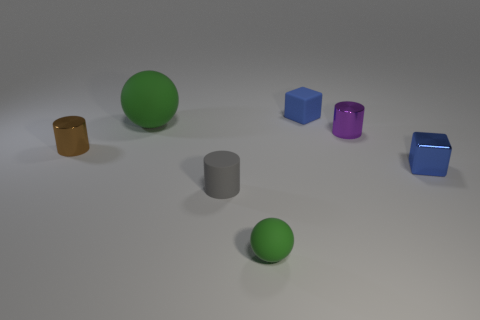Subtract all brown cylinders. How many cylinders are left? 2 Add 3 big matte things. How many objects exist? 10 Subtract all purple cylinders. How many cylinders are left? 2 Subtract all blocks. How many objects are left? 5 Subtract 0 purple spheres. How many objects are left? 7 Subtract all brown cylinders. Subtract all purple balls. How many cylinders are left? 2 Subtract all small purple cylinders. Subtract all purple metal cylinders. How many objects are left? 5 Add 5 purple shiny objects. How many purple shiny objects are left? 6 Add 6 blue rubber objects. How many blue rubber objects exist? 7 